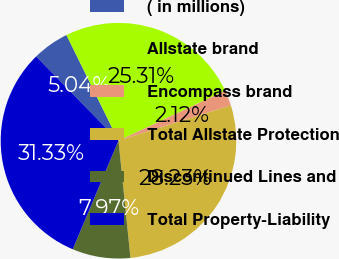Convert chart to OTSL. <chart><loc_0><loc_0><loc_500><loc_500><pie_chart><fcel>( in millions)<fcel>Allstate brand<fcel>Encompass brand<fcel>Total Allstate Protection<fcel>Discontinued Lines and<fcel>Total Property-Liability<nl><fcel>5.04%<fcel>25.31%<fcel>2.12%<fcel>28.23%<fcel>7.97%<fcel>31.33%<nl></chart> 